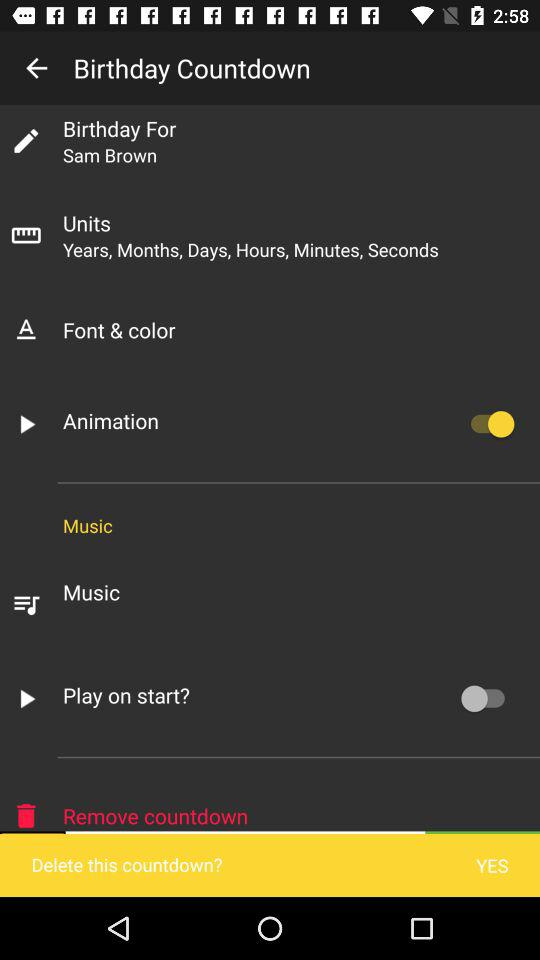What is the status of "Play on start?"? The status of "Play on start?" is "off". 